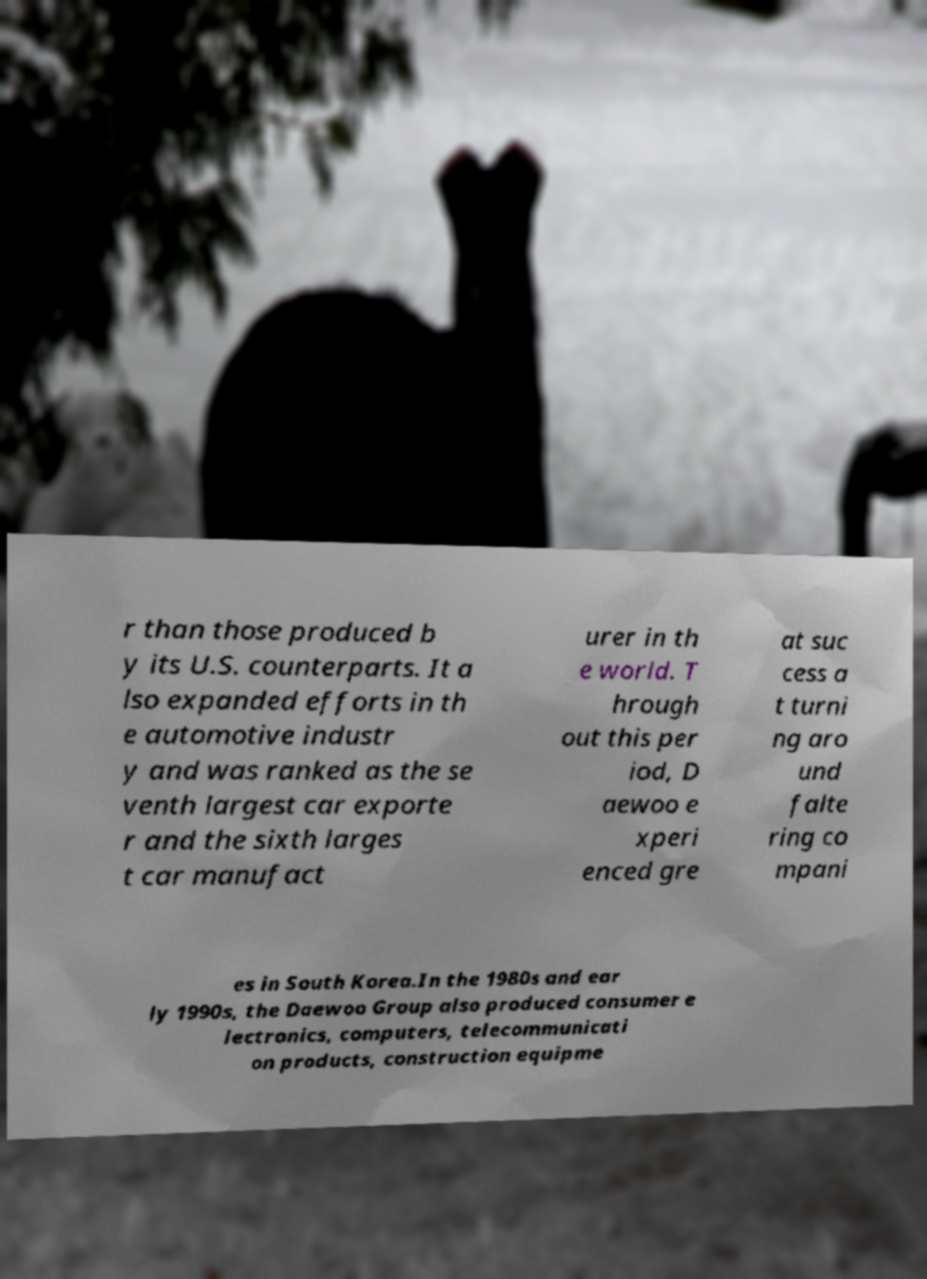Please identify and transcribe the text found in this image. r than those produced b y its U.S. counterparts. It a lso expanded efforts in th e automotive industr y and was ranked as the se venth largest car exporte r and the sixth larges t car manufact urer in th e world. T hrough out this per iod, D aewoo e xperi enced gre at suc cess a t turni ng aro und falte ring co mpani es in South Korea.In the 1980s and ear ly 1990s, the Daewoo Group also produced consumer e lectronics, computers, telecommunicati on products, construction equipme 